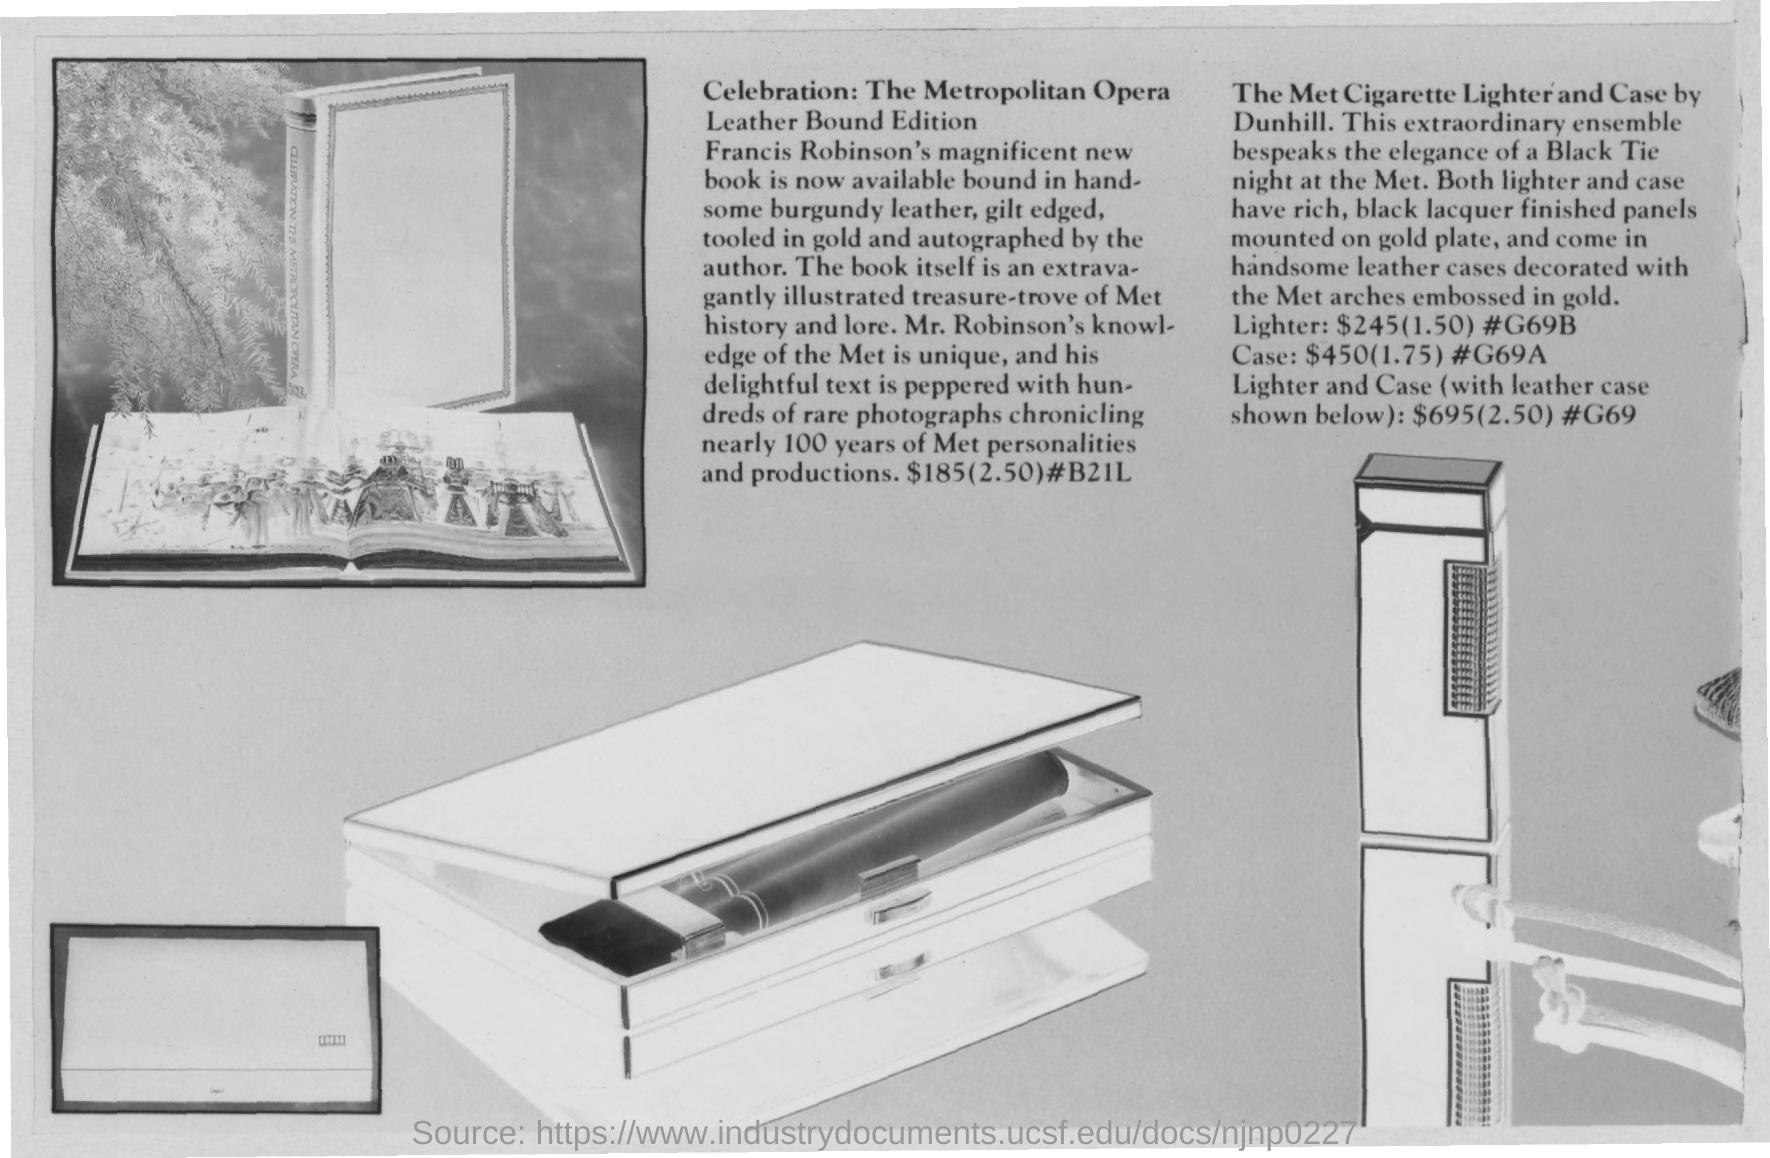Highlight a few significant elements in this photo. The price of the ME cigarette case is $450. The price of the met cigarette case and lighter is $695. Francis Robinson's book, which is now available bound in leather, is a declaration of the author's hard work and dedication to their craft. The physical representation of their book in a durable and luxurious material is a testament to the quality of their writing and the value it holds for readers. The leather binding emphasizes the timeless and enduring nature of the book, making it a treasured possession for those who own it. The price of the met cigarette lighter is $245. The Metropolitan Opera Leather Bound Edition is priced at $185. 